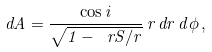<formula> <loc_0><loc_0><loc_500><loc_500>d A = \frac { \cos i } { \sqrt { 1 - \ r S / r } } \, r \, d r \, d \phi \, ,</formula> 